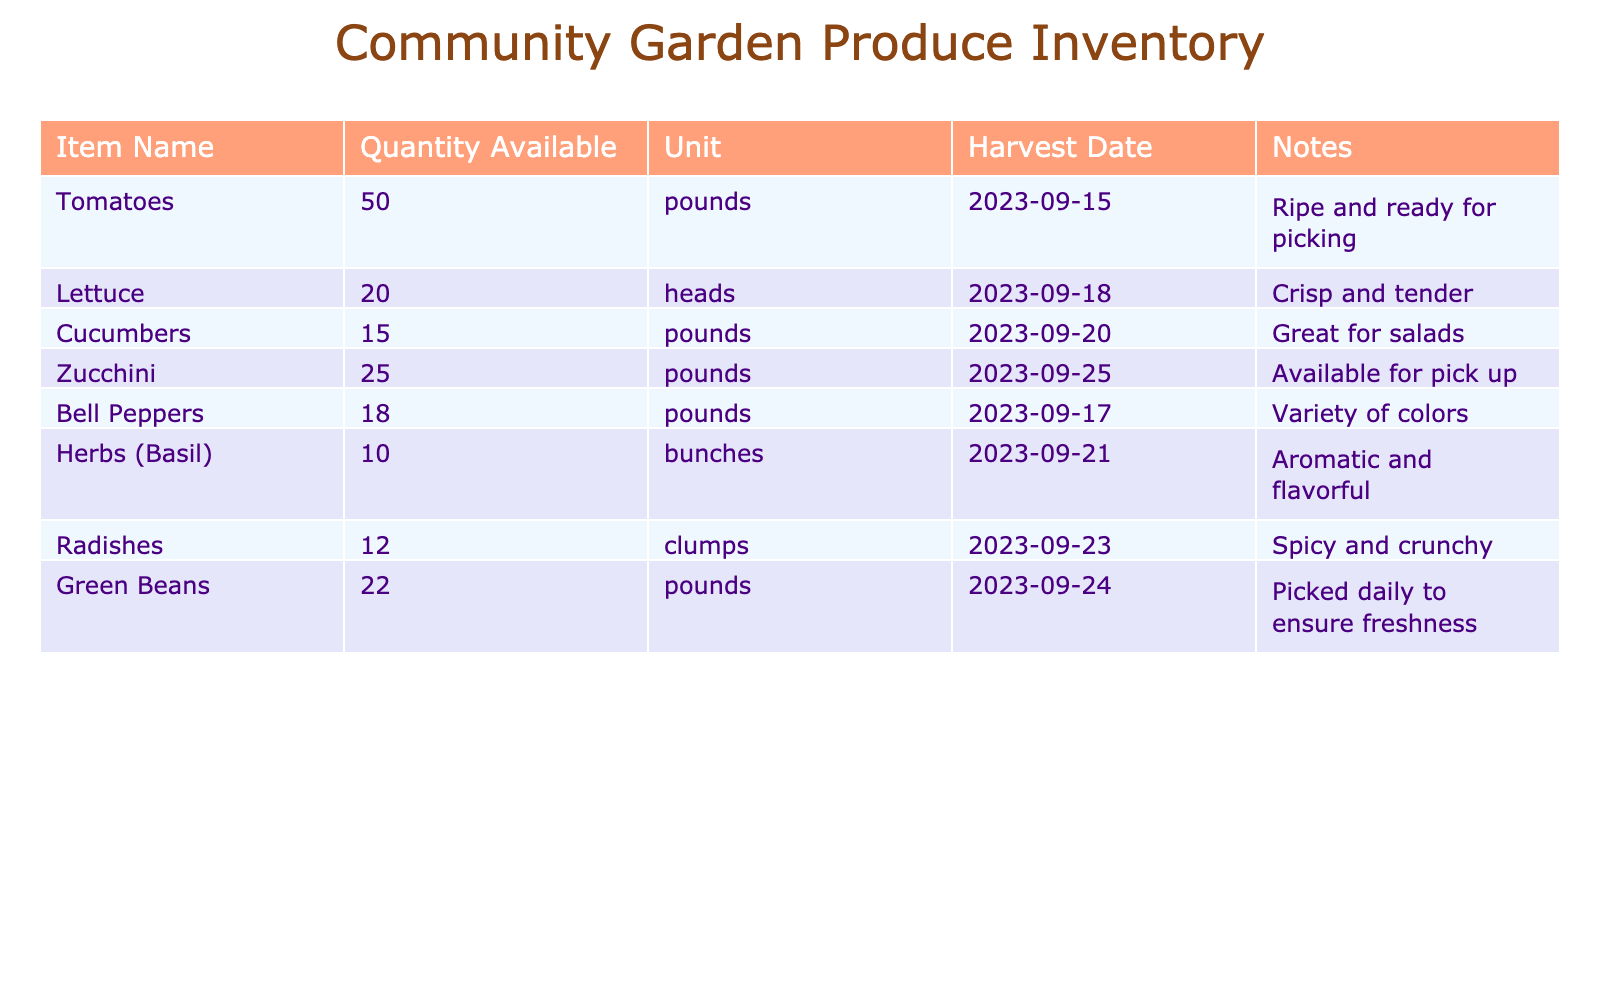What is the quantity available of tomatoes? The table lists the quantity of tomatoes available in the "Quantity Available" column next to the "Item Name" for tomatoes. It shows that there are 50 pounds of tomatoes available.
Answer: 50 pounds When were the bell peppers harvested? The "Harvest Date" column next to the bell peppers in the table indicates when they were harvested. The date shows that bell peppers were harvested on 2023-09-17.
Answer: 2023-09-17 How many clumps of radishes are there compared to cucumbers? The "Quantity Available" for radishes is 12 clumps, while for cucumbers, it is 15 pounds. To compare, cucumbers are more abundant as 15 pounds is greater than 12 clumps.
Answer: Cucumbers are more abundant Is there more lettuce or zucchini available? The table shows 20 heads of lettuce and 25 pounds of zucchini. To determine which is more, we compare the two values directly; since 25 is greater than 20, zucchini is more available.
Answer: Zucchini is more available What is the total quantity of herbs (basil) and green beans available? The "Quantity Available" for herbs (basil) is 10 bunches and for green beans, it is 22 pounds. By adding these two quantities together, we get 10 + 22 = 32. Thus, the total available is 32.
Answer: 32 Are there any ripe produce items available? The notes column shows details about the items. It indicates that tomatoes are "ripe and ready for picking," which confirms that there is at least one ripe produce item available in the inventory.
Answer: Yes When were the cucumbers harvested and how many pounds are available? The "Harvest Date" for cucumbers shows 2023-09-20 in the table, and the quantity available is 15 pounds. Thus, we see both the date and the quantity directly from the relevant columns.
Answer: 2023-09-20, 15 pounds Which item has the largest quantity available and how much is it? By examining the "Quantity Available" column in the table, we see tomatoes (50 pounds) and zucchini (25 pounds), but tomatoes have the largest quantity. The value indicates 50 pounds.
Answer: Tomatoes, 50 pounds How many items in total are available in the community garden? To find the total quantity of all items available in the garden, we add together all the available quantities: 50 (tomatoes) + 20 (lettuce) + 15 (cucumbers) + 25 (zucchini) + 18 (bell peppers) + 10 (herbs) + 12 (radishes) + 22 (green beans) = 172.
Answer: 172 